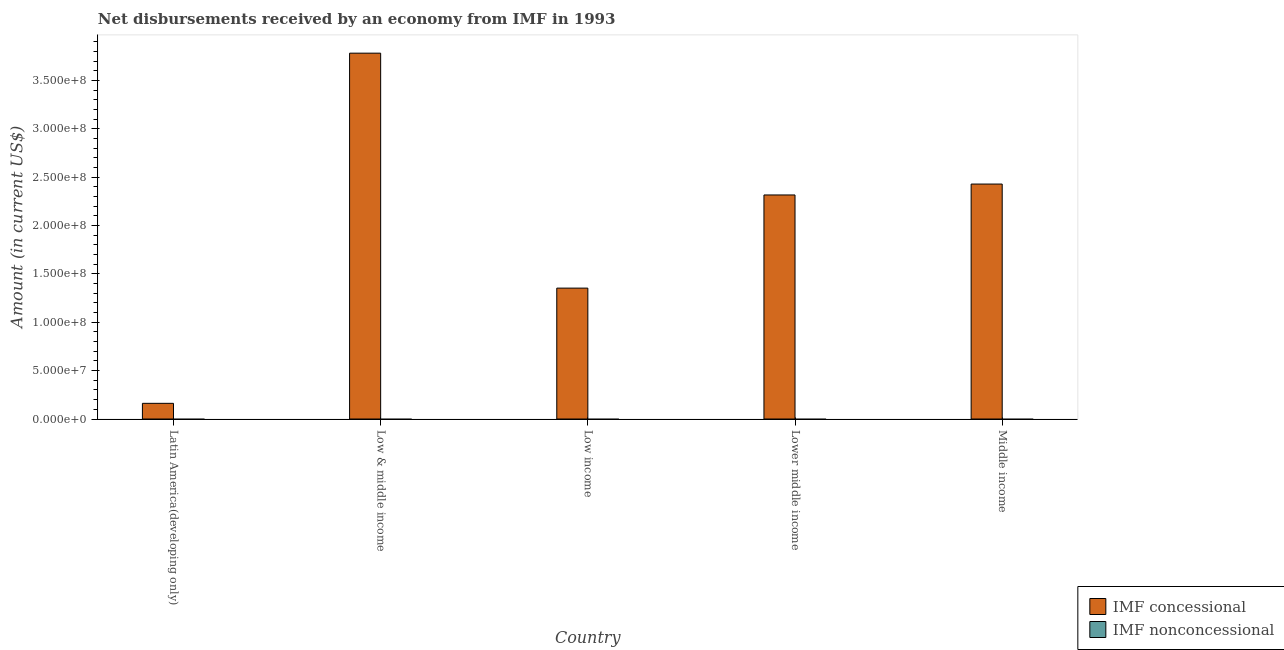Are the number of bars per tick equal to the number of legend labels?
Your response must be concise. No. Are the number of bars on each tick of the X-axis equal?
Ensure brevity in your answer.  Yes. How many bars are there on the 2nd tick from the right?
Offer a terse response. 1. What is the label of the 4th group of bars from the left?
Your answer should be very brief. Lower middle income. What is the net concessional disbursements from imf in Middle income?
Offer a very short reply. 2.43e+08. Across all countries, what is the maximum net concessional disbursements from imf?
Keep it short and to the point. 3.78e+08. Across all countries, what is the minimum net concessional disbursements from imf?
Your response must be concise. 1.62e+07. In which country was the net concessional disbursements from imf maximum?
Offer a terse response. Low & middle income. What is the difference between the net concessional disbursements from imf in Latin America(developing only) and that in Lower middle income?
Your answer should be very brief. -2.15e+08. What is the difference between the net non concessional disbursements from imf in Latin America(developing only) and the net concessional disbursements from imf in Low income?
Your answer should be compact. -1.35e+08. What is the average net concessional disbursements from imf per country?
Offer a very short reply. 2.01e+08. What is the ratio of the net concessional disbursements from imf in Latin America(developing only) to that in Low income?
Provide a short and direct response. 0.12. Is the net concessional disbursements from imf in Latin America(developing only) less than that in Low income?
Offer a terse response. Yes. What is the difference between the highest and the second highest net concessional disbursements from imf?
Provide a succinct answer. 1.35e+08. What is the difference between the highest and the lowest net concessional disbursements from imf?
Give a very brief answer. 3.62e+08. In how many countries, is the net concessional disbursements from imf greater than the average net concessional disbursements from imf taken over all countries?
Offer a very short reply. 3. How many countries are there in the graph?
Make the answer very short. 5. Does the graph contain any zero values?
Ensure brevity in your answer.  Yes. Does the graph contain grids?
Provide a succinct answer. No. How are the legend labels stacked?
Your answer should be very brief. Vertical. What is the title of the graph?
Make the answer very short. Net disbursements received by an economy from IMF in 1993. What is the Amount (in current US$) in IMF concessional in Latin America(developing only)?
Make the answer very short. 1.62e+07. What is the Amount (in current US$) in IMF nonconcessional in Latin America(developing only)?
Give a very brief answer. 0. What is the Amount (in current US$) in IMF concessional in Low & middle income?
Make the answer very short. 3.78e+08. What is the Amount (in current US$) in IMF nonconcessional in Low & middle income?
Provide a succinct answer. 0. What is the Amount (in current US$) of IMF concessional in Low income?
Make the answer very short. 1.35e+08. What is the Amount (in current US$) in IMF nonconcessional in Low income?
Your answer should be compact. 0. What is the Amount (in current US$) in IMF concessional in Lower middle income?
Provide a succinct answer. 2.32e+08. What is the Amount (in current US$) of IMF concessional in Middle income?
Keep it short and to the point. 2.43e+08. What is the Amount (in current US$) of IMF nonconcessional in Middle income?
Offer a terse response. 0. Across all countries, what is the maximum Amount (in current US$) in IMF concessional?
Your answer should be compact. 3.78e+08. Across all countries, what is the minimum Amount (in current US$) of IMF concessional?
Offer a terse response. 1.62e+07. What is the total Amount (in current US$) in IMF concessional in the graph?
Provide a succinct answer. 1.00e+09. What is the difference between the Amount (in current US$) in IMF concessional in Latin America(developing only) and that in Low & middle income?
Ensure brevity in your answer.  -3.62e+08. What is the difference between the Amount (in current US$) in IMF concessional in Latin America(developing only) and that in Low income?
Ensure brevity in your answer.  -1.19e+08. What is the difference between the Amount (in current US$) in IMF concessional in Latin America(developing only) and that in Lower middle income?
Give a very brief answer. -2.15e+08. What is the difference between the Amount (in current US$) of IMF concessional in Latin America(developing only) and that in Middle income?
Your answer should be very brief. -2.27e+08. What is the difference between the Amount (in current US$) of IMF concessional in Low & middle income and that in Low income?
Make the answer very short. 2.43e+08. What is the difference between the Amount (in current US$) in IMF concessional in Low & middle income and that in Lower middle income?
Give a very brief answer. 1.47e+08. What is the difference between the Amount (in current US$) of IMF concessional in Low & middle income and that in Middle income?
Keep it short and to the point. 1.35e+08. What is the difference between the Amount (in current US$) in IMF concessional in Low income and that in Lower middle income?
Your response must be concise. -9.63e+07. What is the difference between the Amount (in current US$) in IMF concessional in Low income and that in Middle income?
Offer a terse response. -1.08e+08. What is the difference between the Amount (in current US$) in IMF concessional in Lower middle income and that in Middle income?
Offer a very short reply. -1.13e+07. What is the average Amount (in current US$) in IMF concessional per country?
Your response must be concise. 2.01e+08. What is the ratio of the Amount (in current US$) in IMF concessional in Latin America(developing only) to that in Low & middle income?
Ensure brevity in your answer.  0.04. What is the ratio of the Amount (in current US$) in IMF concessional in Latin America(developing only) to that in Low income?
Give a very brief answer. 0.12. What is the ratio of the Amount (in current US$) of IMF concessional in Latin America(developing only) to that in Lower middle income?
Offer a terse response. 0.07. What is the ratio of the Amount (in current US$) of IMF concessional in Latin America(developing only) to that in Middle income?
Offer a terse response. 0.07. What is the ratio of the Amount (in current US$) in IMF concessional in Low & middle income to that in Low income?
Your answer should be compact. 2.79. What is the ratio of the Amount (in current US$) in IMF concessional in Low & middle income to that in Lower middle income?
Offer a terse response. 1.63. What is the ratio of the Amount (in current US$) in IMF concessional in Low & middle income to that in Middle income?
Offer a terse response. 1.56. What is the ratio of the Amount (in current US$) of IMF concessional in Low income to that in Lower middle income?
Ensure brevity in your answer.  0.58. What is the ratio of the Amount (in current US$) of IMF concessional in Low income to that in Middle income?
Your response must be concise. 0.56. What is the ratio of the Amount (in current US$) in IMF concessional in Lower middle income to that in Middle income?
Your answer should be compact. 0.95. What is the difference between the highest and the second highest Amount (in current US$) in IMF concessional?
Your answer should be very brief. 1.35e+08. What is the difference between the highest and the lowest Amount (in current US$) of IMF concessional?
Make the answer very short. 3.62e+08. 